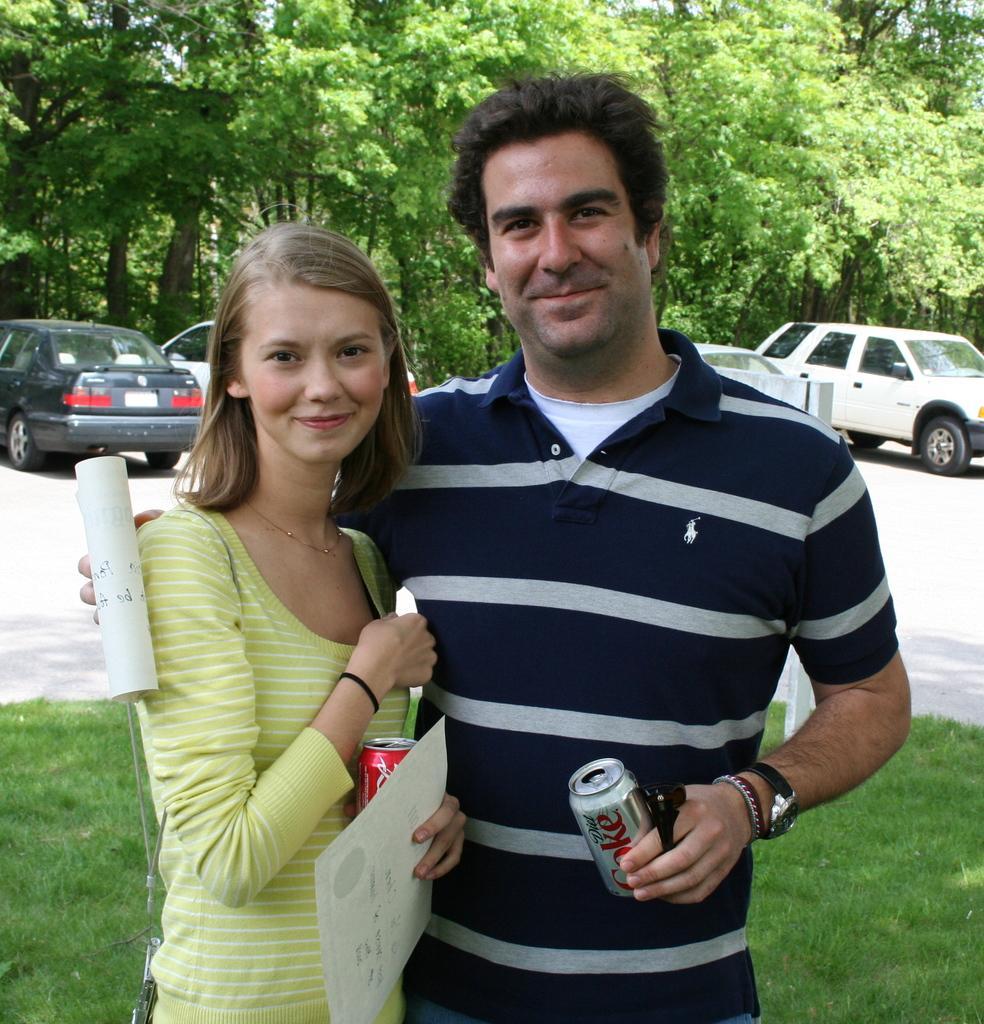Describe this image in one or two sentences. In this picture we can see a man and woman, they both are smiling, and they are holding tins and papers, in the background we can see few cars and trees. 